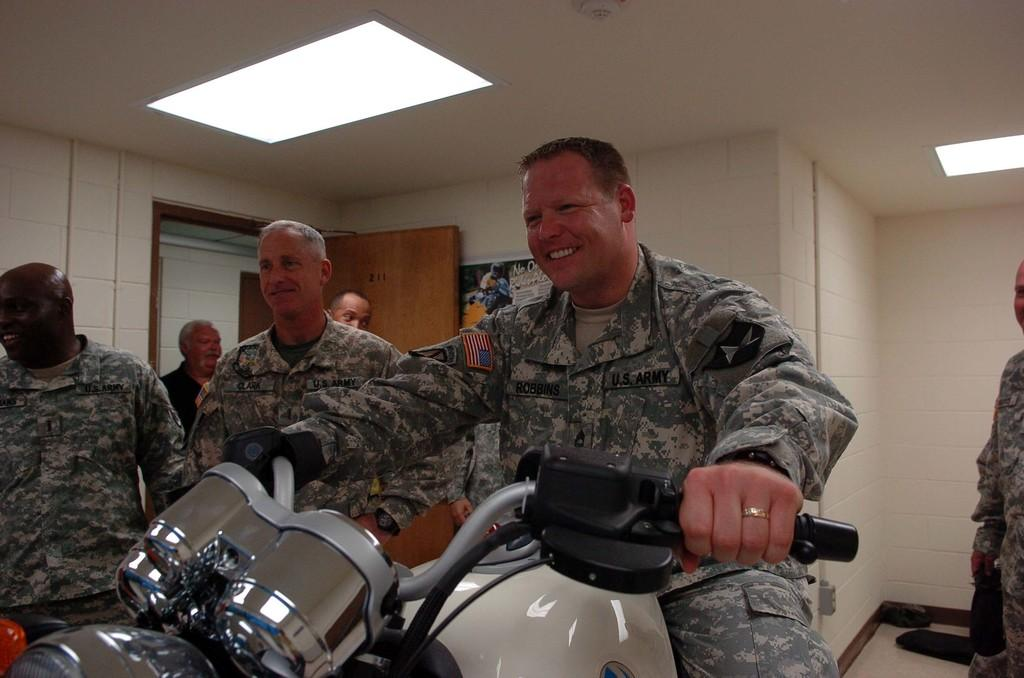What is the man in the image doing? The man is sitting and holding a bike. Are there any other people in the image? Yes, there are people standing nearby. What can be seen in the background of the image? There is a poster on a wall and a door in the background. What is visible at the top of the image? There are lights visible at the top of the image. What verse is the man reciting in the image? There is no indication in the image that the man is reciting a verse, so it cannot be determined from the picture. 